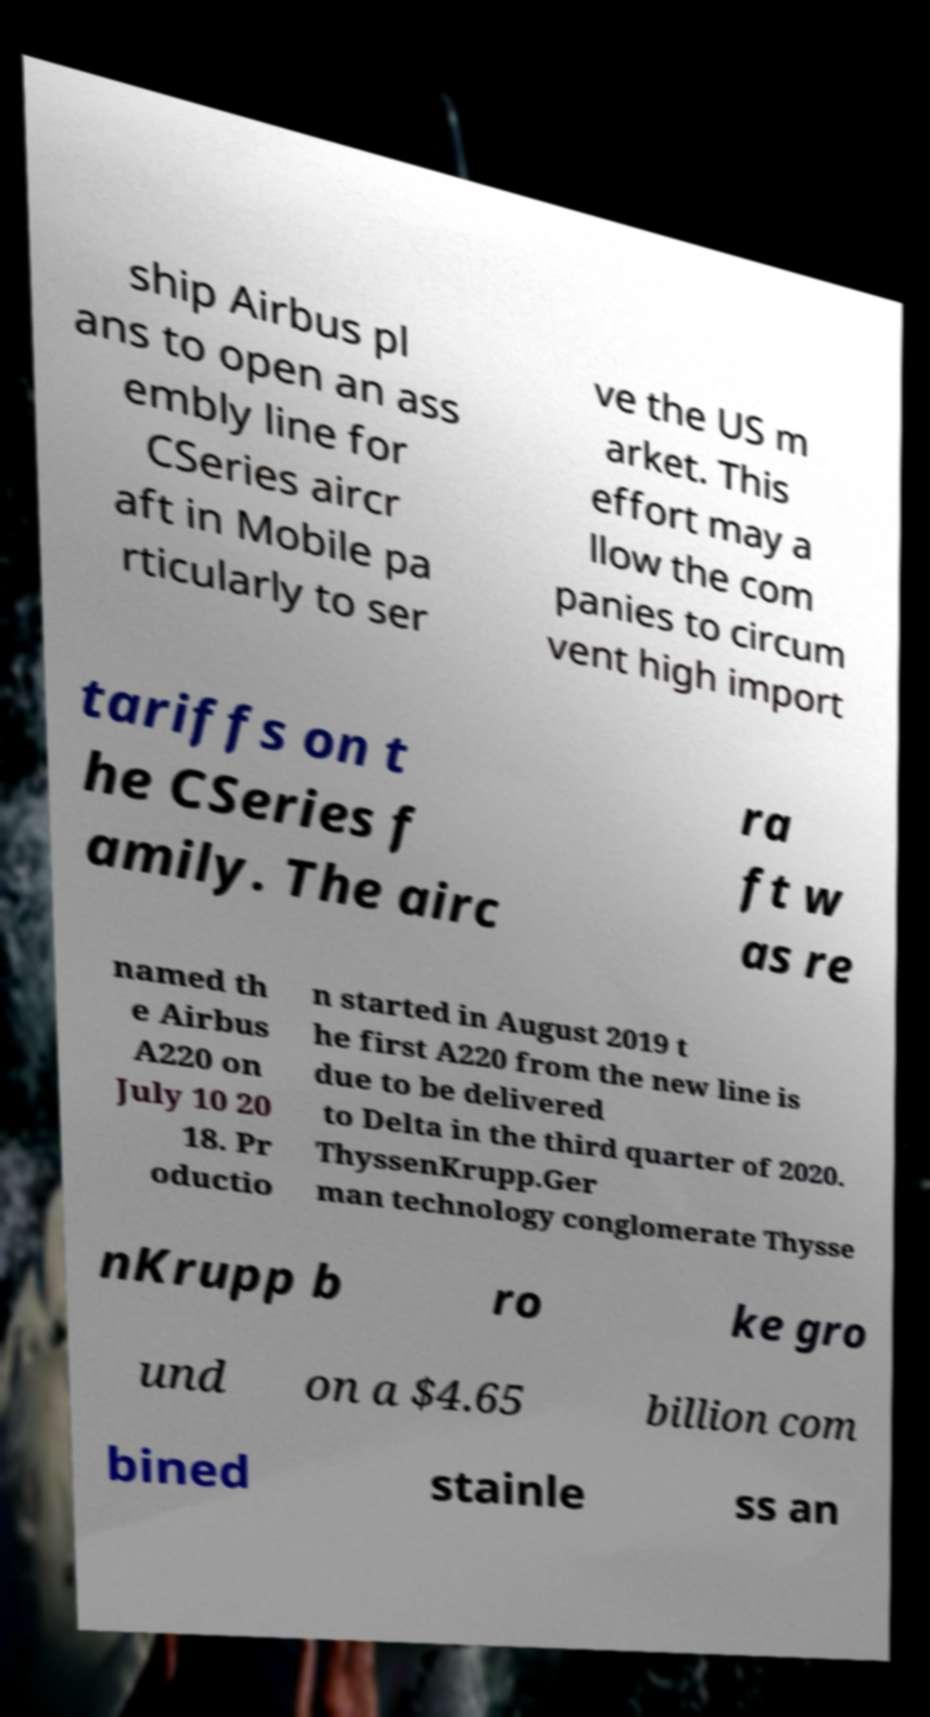Can you accurately transcribe the text from the provided image for me? ship Airbus pl ans to open an ass embly line for CSeries aircr aft in Mobile pa rticularly to ser ve the US m arket. This effort may a llow the com panies to circum vent high import tariffs on t he CSeries f amily. The airc ra ft w as re named th e Airbus A220 on July 10 20 18. Pr oductio n started in August 2019 t he first A220 from the new line is due to be delivered to Delta in the third quarter of 2020. ThyssenKrupp.Ger man technology conglomerate Thysse nKrupp b ro ke gro und on a $4.65 billion com bined stainle ss an 